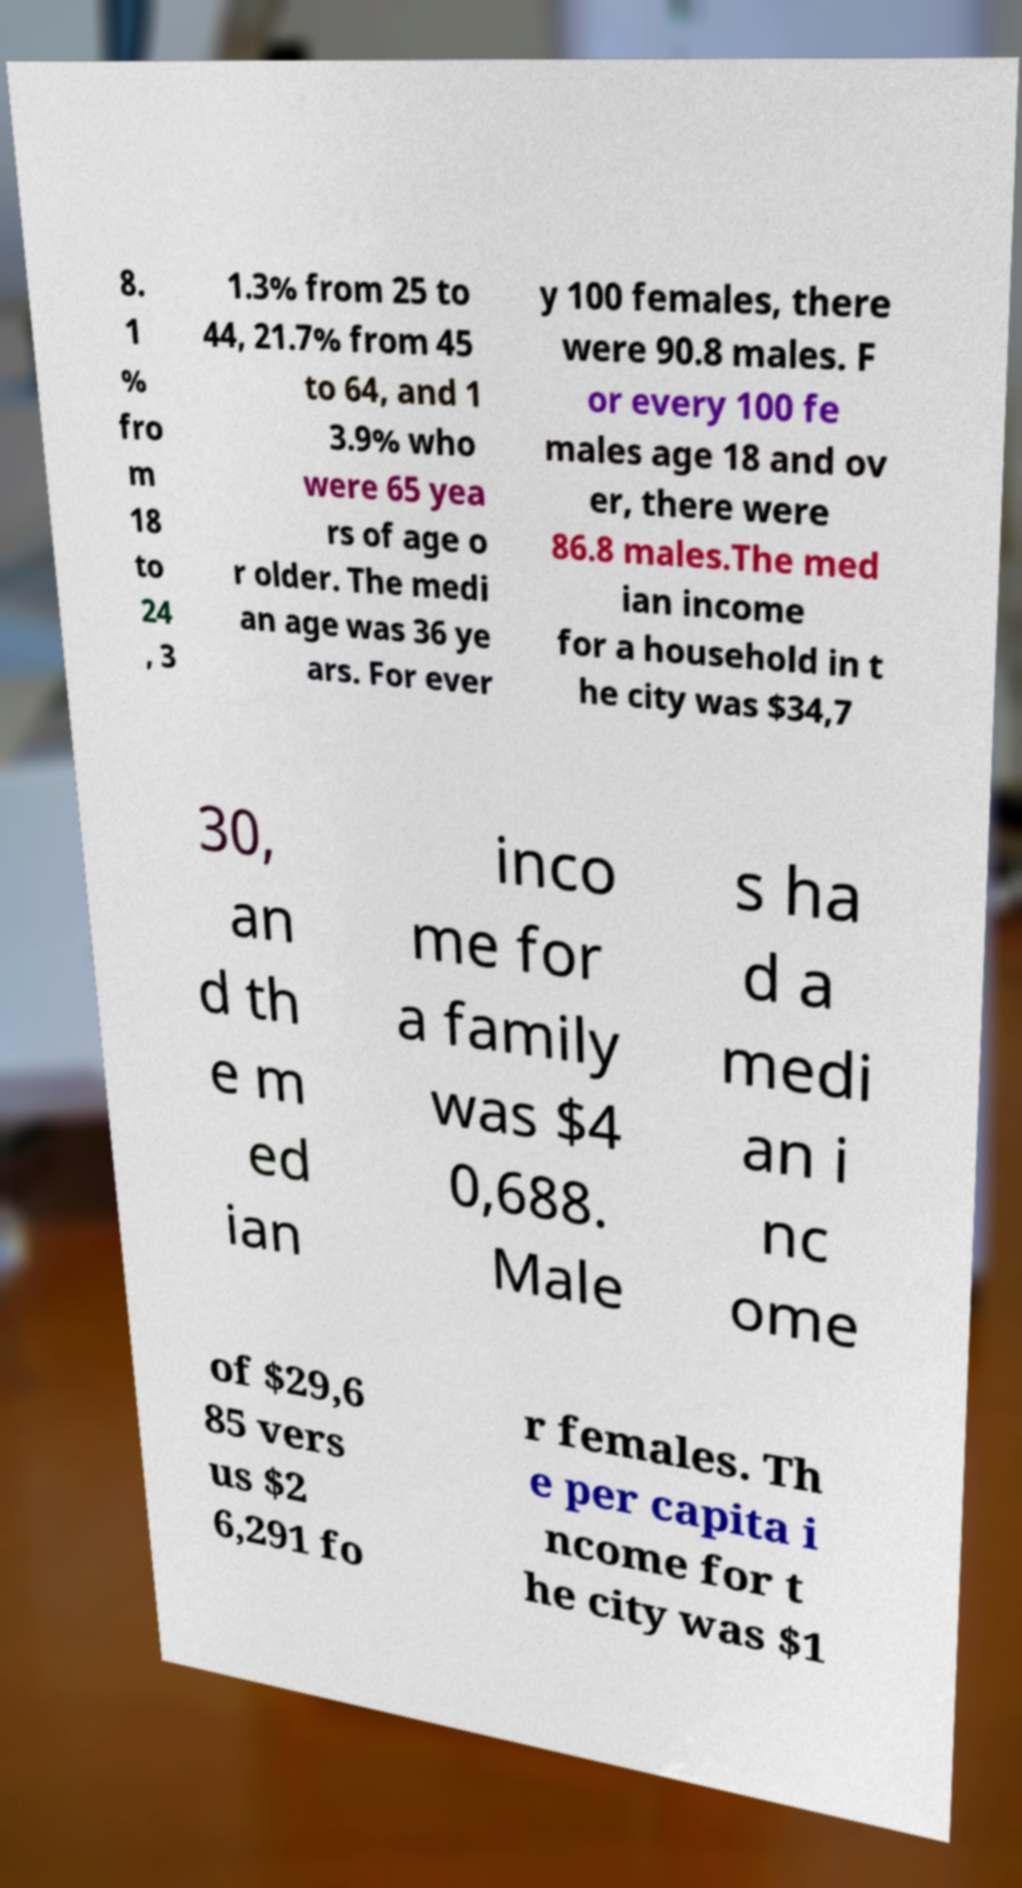What messages or text are displayed in this image? I need them in a readable, typed format. 8. 1 % fro m 18 to 24 , 3 1.3% from 25 to 44, 21.7% from 45 to 64, and 1 3.9% who were 65 yea rs of age o r older. The medi an age was 36 ye ars. For ever y 100 females, there were 90.8 males. F or every 100 fe males age 18 and ov er, there were 86.8 males.The med ian income for a household in t he city was $34,7 30, an d th e m ed ian inco me for a family was $4 0,688. Male s ha d a medi an i nc ome of $29,6 85 vers us $2 6,291 fo r females. Th e per capita i ncome for t he city was $1 